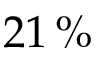<formula> <loc_0><loc_0><loc_500><loc_500>2 1 \, \%</formula> 